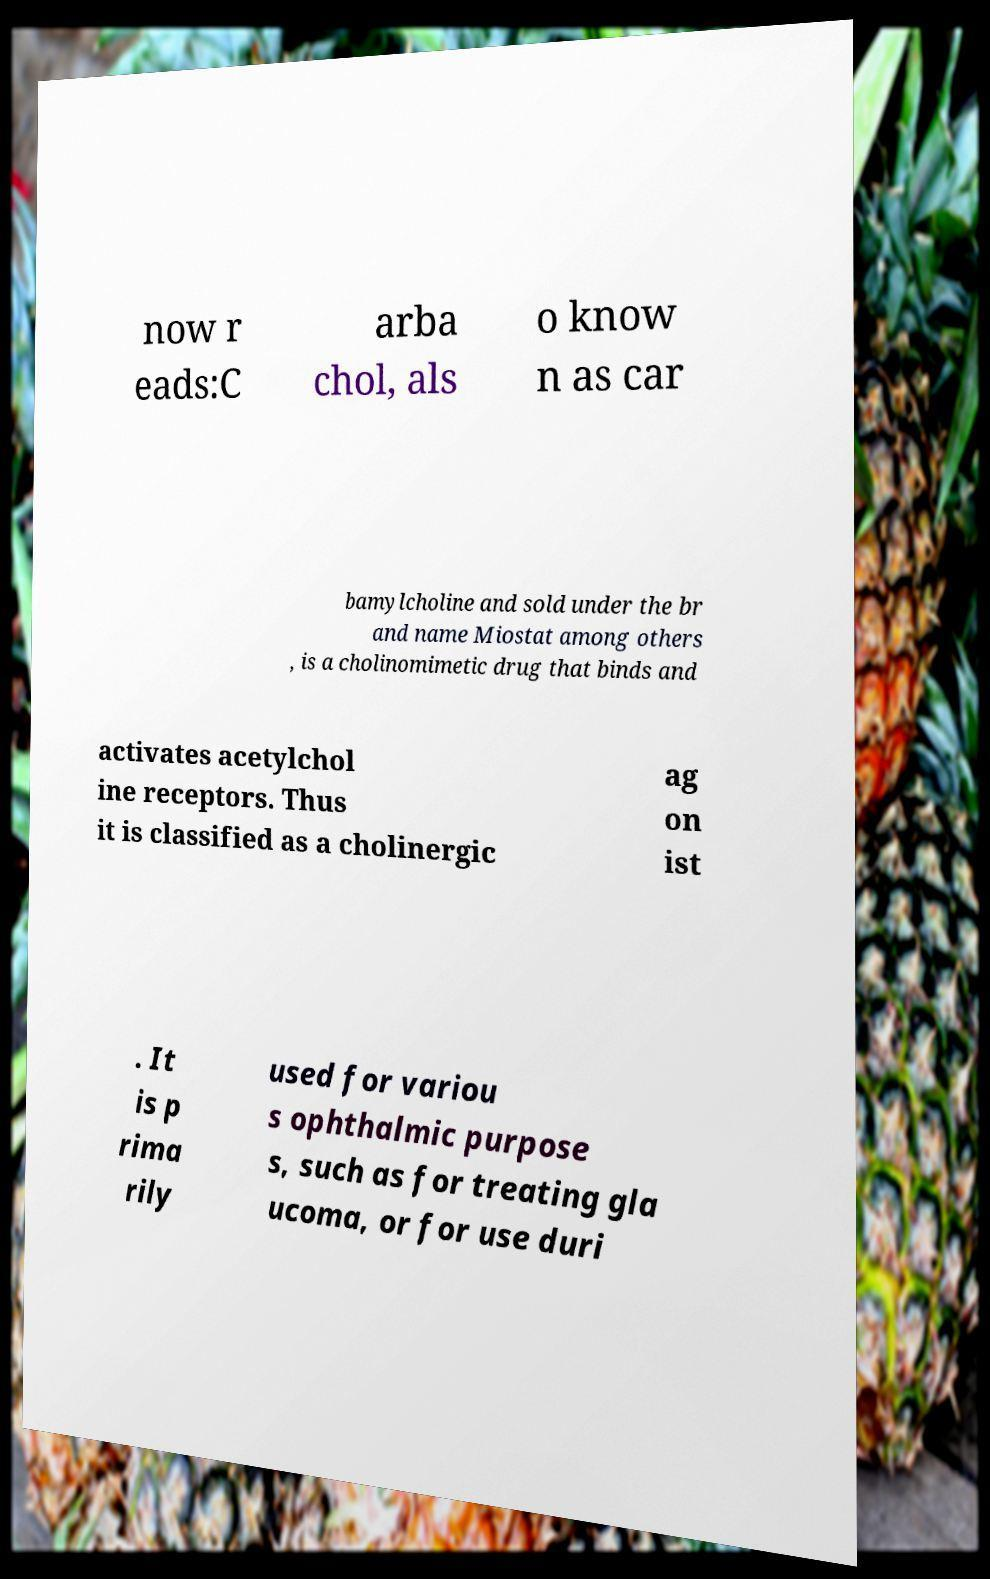For documentation purposes, I need the text within this image transcribed. Could you provide that? now r eads:C arba chol, als o know n as car bamylcholine and sold under the br and name Miostat among others , is a cholinomimetic drug that binds and activates acetylchol ine receptors. Thus it is classified as a cholinergic ag on ist . It is p rima rily used for variou s ophthalmic purpose s, such as for treating gla ucoma, or for use duri 